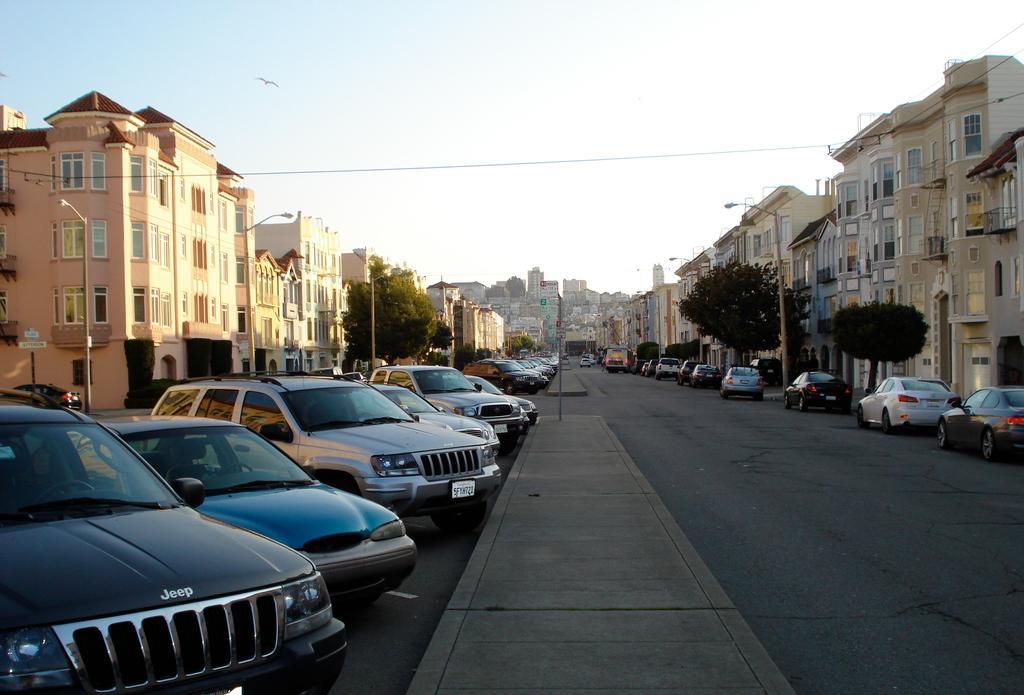Can you describe this image briefly? In this image I can see fleets of cars on the road. In the background I can see trees, poles, buildings, and windows. On the top I can see the sky. This image is taken during a day. 